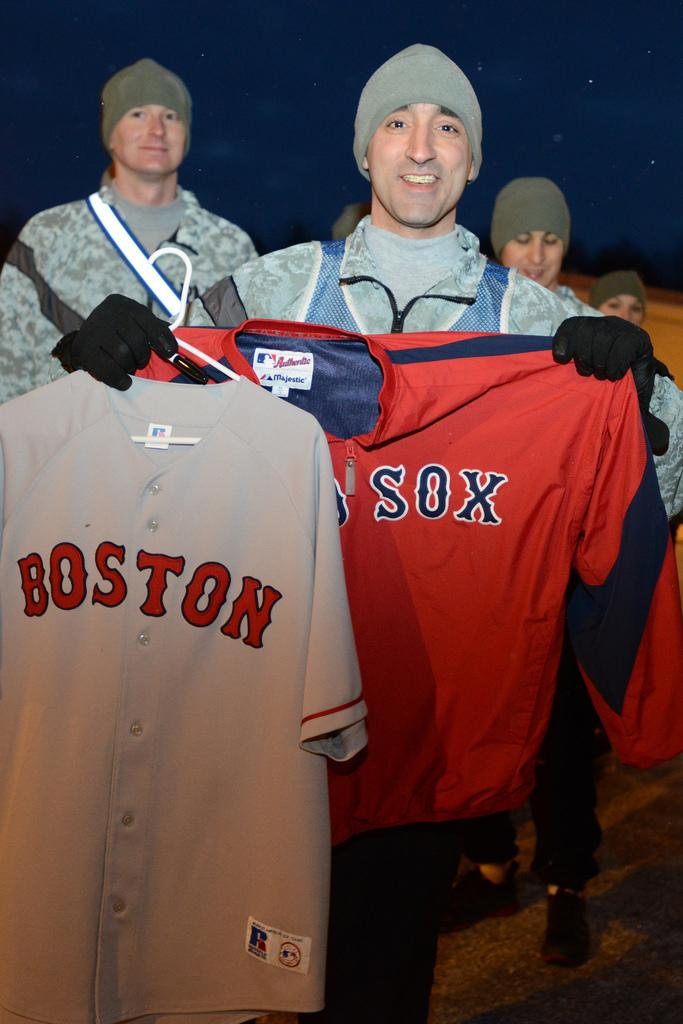Provide a one-sentence caption for the provided image. A man holds two Boston Red Sox shirts up to the camera. 